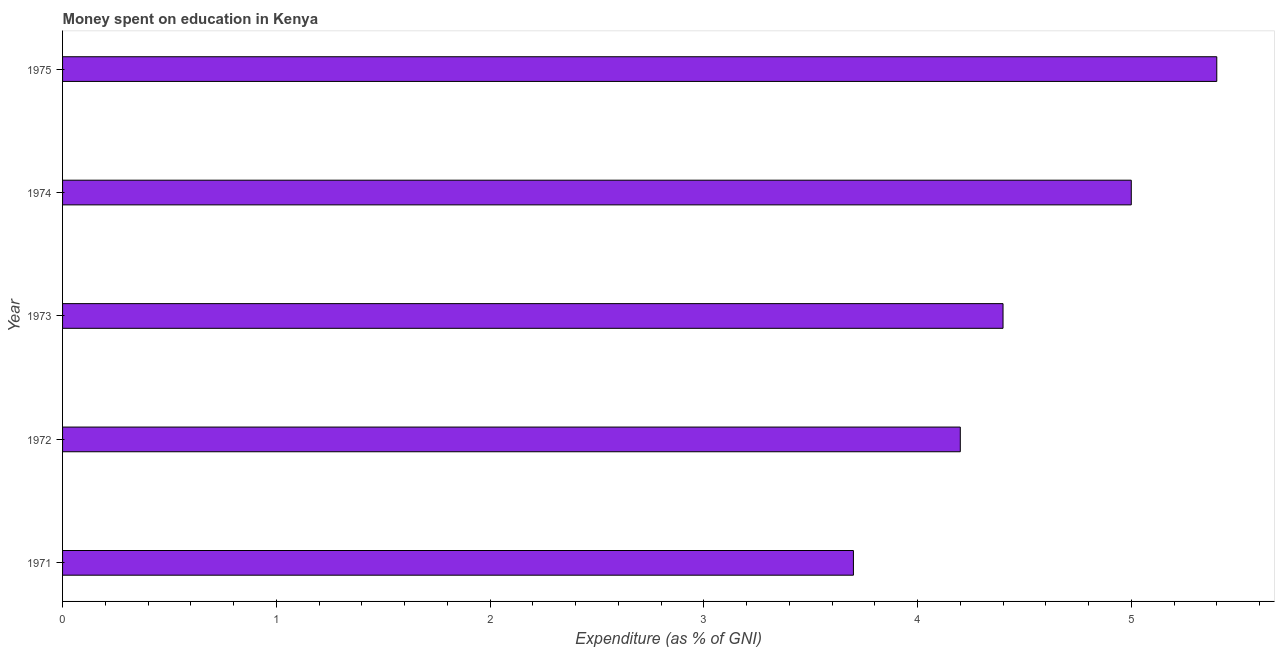Does the graph contain any zero values?
Your answer should be compact. No. Does the graph contain grids?
Provide a succinct answer. No. What is the title of the graph?
Your answer should be compact. Money spent on education in Kenya. What is the label or title of the X-axis?
Keep it short and to the point. Expenditure (as % of GNI). What is the label or title of the Y-axis?
Keep it short and to the point. Year. Across all years, what is the minimum expenditure on education?
Keep it short and to the point. 3.7. In which year was the expenditure on education maximum?
Offer a very short reply. 1975. What is the sum of the expenditure on education?
Offer a very short reply. 22.7. What is the difference between the expenditure on education in 1973 and 1974?
Your answer should be very brief. -0.6. What is the average expenditure on education per year?
Your answer should be very brief. 4.54. In how many years, is the expenditure on education greater than 2.2 %?
Provide a succinct answer. 5. What is the ratio of the expenditure on education in 1974 to that in 1975?
Offer a very short reply. 0.93. Is the expenditure on education in 1971 less than that in 1972?
Your response must be concise. Yes. Is the difference between the expenditure on education in 1971 and 1975 greater than the difference between any two years?
Offer a terse response. Yes. What is the difference between two consecutive major ticks on the X-axis?
Offer a terse response. 1. Are the values on the major ticks of X-axis written in scientific E-notation?
Offer a very short reply. No. What is the difference between the Expenditure (as % of GNI) in 1971 and 1972?
Keep it short and to the point. -0.5. What is the difference between the Expenditure (as % of GNI) in 1971 and 1973?
Offer a very short reply. -0.7. What is the difference between the Expenditure (as % of GNI) in 1971 and 1974?
Offer a terse response. -1.3. What is the difference between the Expenditure (as % of GNI) in 1973 and 1974?
Give a very brief answer. -0.6. What is the difference between the Expenditure (as % of GNI) in 1974 and 1975?
Give a very brief answer. -0.4. What is the ratio of the Expenditure (as % of GNI) in 1971 to that in 1972?
Make the answer very short. 0.88. What is the ratio of the Expenditure (as % of GNI) in 1971 to that in 1973?
Provide a succinct answer. 0.84. What is the ratio of the Expenditure (as % of GNI) in 1971 to that in 1974?
Provide a succinct answer. 0.74. What is the ratio of the Expenditure (as % of GNI) in 1971 to that in 1975?
Your answer should be compact. 0.69. What is the ratio of the Expenditure (as % of GNI) in 1972 to that in 1973?
Your response must be concise. 0.95. What is the ratio of the Expenditure (as % of GNI) in 1972 to that in 1974?
Give a very brief answer. 0.84. What is the ratio of the Expenditure (as % of GNI) in 1972 to that in 1975?
Ensure brevity in your answer.  0.78. What is the ratio of the Expenditure (as % of GNI) in 1973 to that in 1975?
Ensure brevity in your answer.  0.81. What is the ratio of the Expenditure (as % of GNI) in 1974 to that in 1975?
Keep it short and to the point. 0.93. 